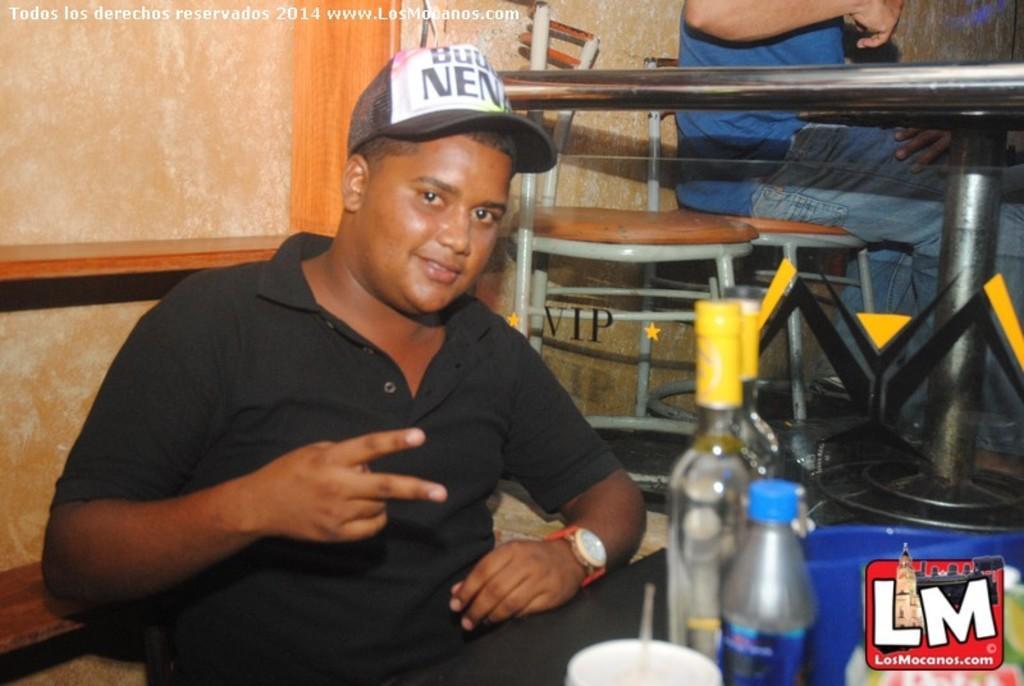In one or two sentences, can you explain what this image depicts? In the image we can see there is a person who is sitting and on table there are wine bottles, juice bottle and a cup. 